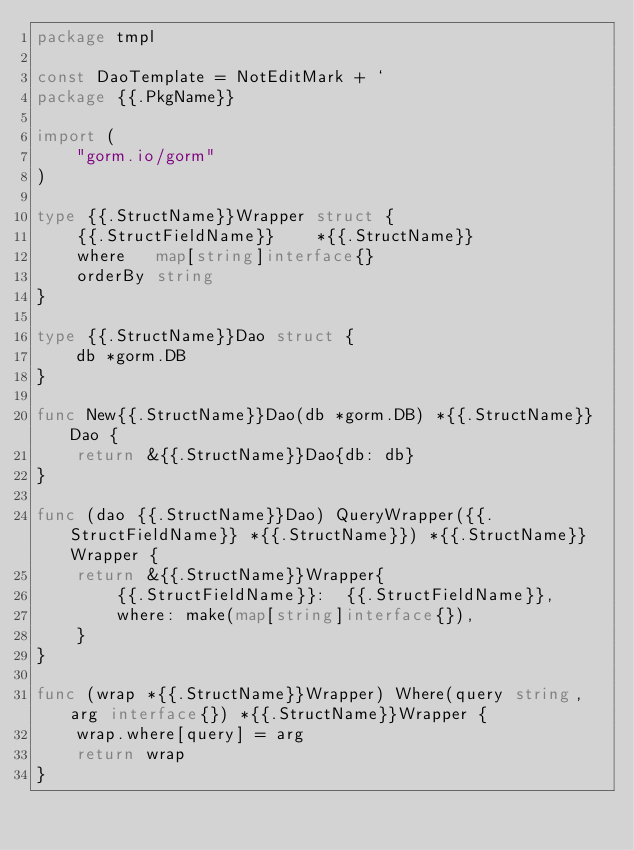Convert code to text. <code><loc_0><loc_0><loc_500><loc_500><_Go_>package tmpl

const DaoTemplate = NotEditMark + `
package {{.PkgName}}

import (
	"gorm.io/gorm"
)

type {{.StructName}}Wrapper struct {
	{{.StructFieldName}}    *{{.StructName}}
	where   map[string]interface{}
	orderBy string
}

type {{.StructName}}Dao struct {
	db *gorm.DB
}

func New{{.StructName}}Dao(db *gorm.DB) *{{.StructName}}Dao {
	return &{{.StructName}}Dao{db: db}
}

func (dao {{.StructName}}Dao) QueryWrapper({{.StructFieldName}} *{{.StructName}}) *{{.StructName}}Wrapper {
	return &{{.StructName}}Wrapper{
		{{.StructFieldName}}:  {{.StructFieldName}},
		where: make(map[string]interface{}),
	}
}

func (wrap *{{.StructName}}Wrapper) Where(query string, arg interface{}) *{{.StructName}}Wrapper {
	wrap.where[query] = arg
	return wrap
}
</code> 